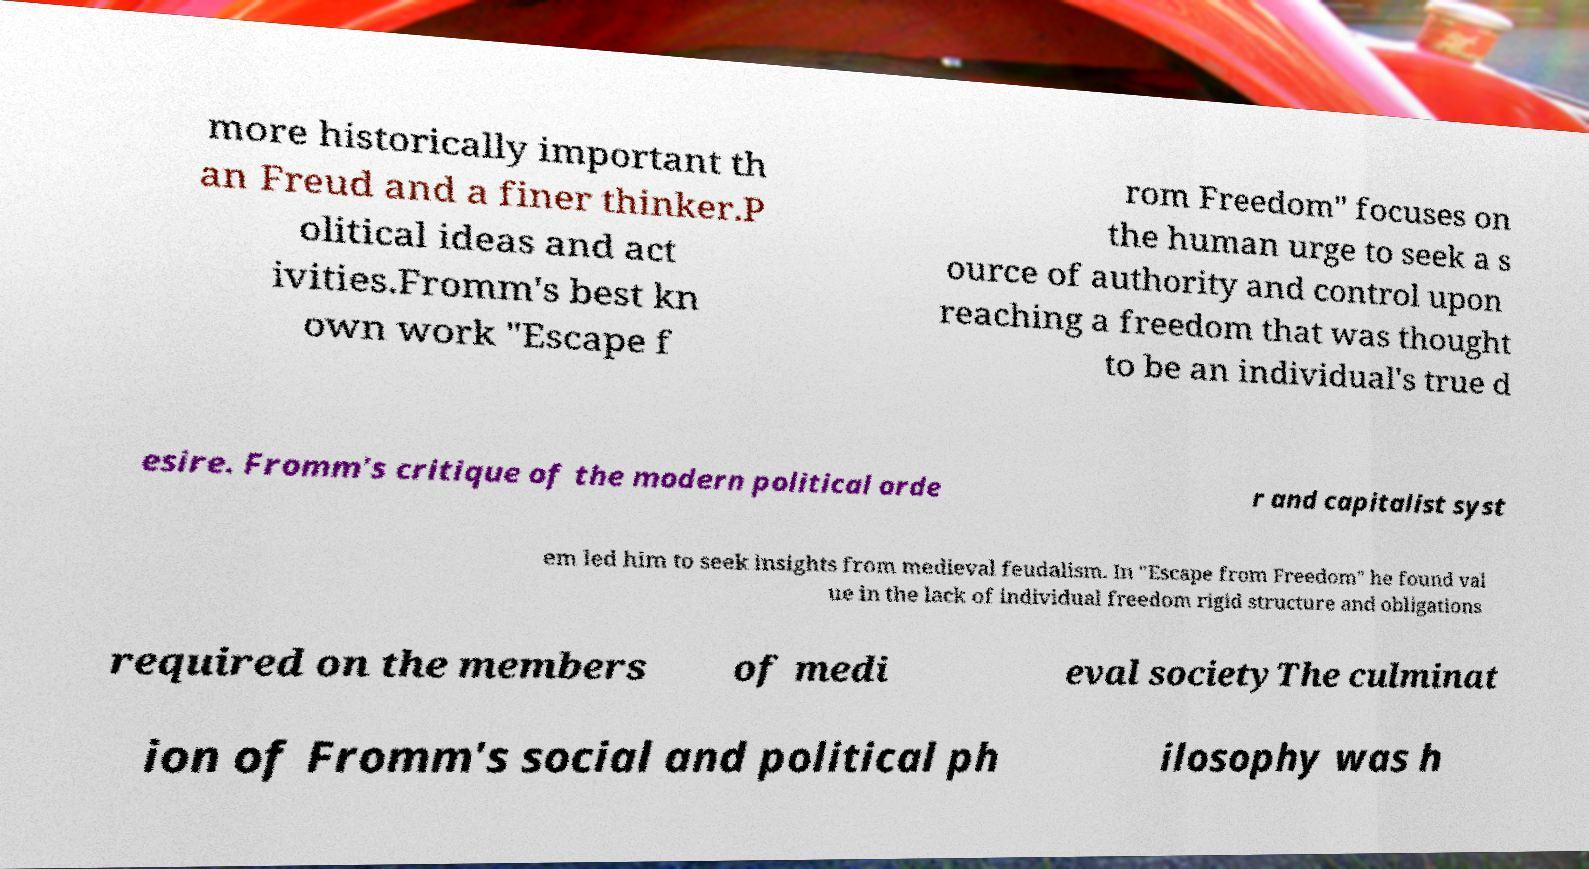For documentation purposes, I need the text within this image transcribed. Could you provide that? more historically important th an Freud and a finer thinker.P olitical ideas and act ivities.Fromm's best kn own work "Escape f rom Freedom" focuses on the human urge to seek a s ource of authority and control upon reaching a freedom that was thought to be an individual's true d esire. Fromm's critique of the modern political orde r and capitalist syst em led him to seek insights from medieval feudalism. In "Escape from Freedom" he found val ue in the lack of individual freedom rigid structure and obligations required on the members of medi eval societyThe culminat ion of Fromm's social and political ph ilosophy was h 